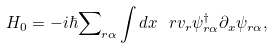<formula> <loc_0><loc_0><loc_500><loc_500>H _ { 0 } = - i \hbar { \sum } _ { r \alpha } \int d x \ r v _ { r } \psi _ { r \alpha } ^ { \dagger } \partial _ { x } \psi _ { r \alpha } ,</formula> 